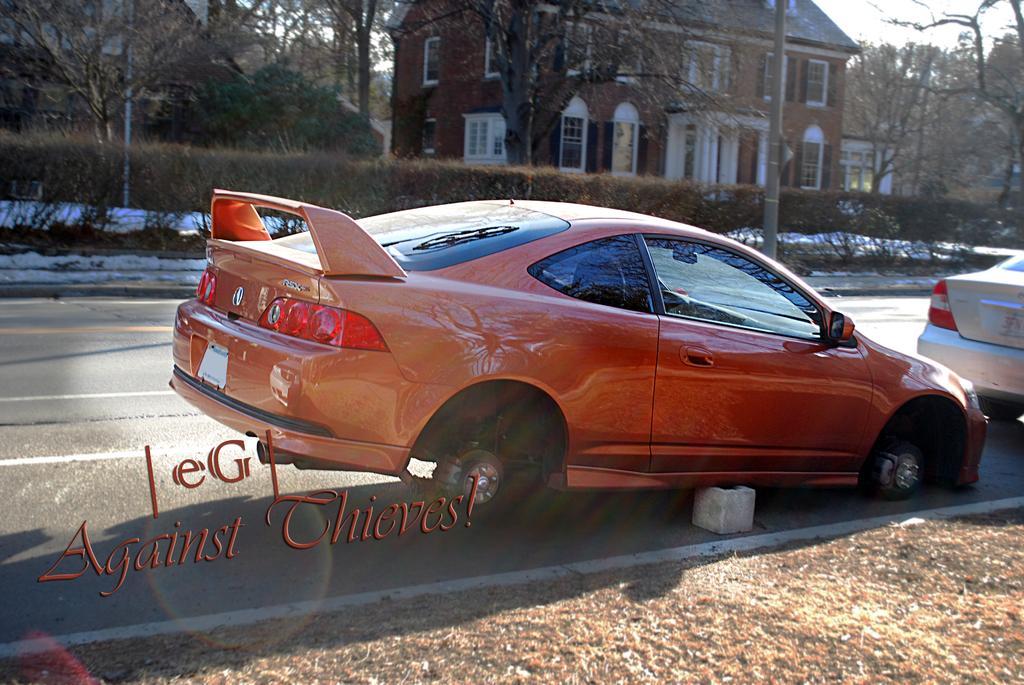Describe this image in one or two sentences. In this image I can see there are two vehicles visible on road , there is a text visible back side of vehicle and at the top there is a building , trees ,bushes. 